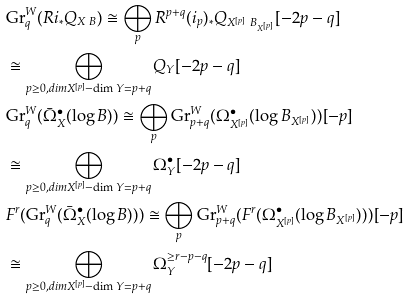Convert formula to latex. <formula><loc_0><loc_0><loc_500><loc_500>& \text {Gr} _ { q } ^ { W } ( R i _ { * } Q _ { X \ B } ) \cong \bigoplus _ { p } R ^ { p + q } ( i _ { p } ) _ { * } Q _ { X ^ { [ p ] } \ B _ { X ^ { [ p ] } } } [ - 2 p - q ] \\ & \cong \bigoplus _ { p \geq 0 , d i m X ^ { [ p ] } - \dim Y = p + q } Q _ { Y } [ - 2 p - q ] \\ & \text {Gr} _ { q } ^ { W } ( \bar { \Omega } ^ { \bullet } _ { X } ( \log B ) ) \cong \bigoplus _ { p } \text {Gr} _ { p + q } ^ { W } ( \Omega ^ { \bullet } _ { X ^ { [ p ] } } ( \log B _ { X ^ { [ p ] } } ) ) [ - p ] \\ & \cong \bigoplus _ { p \geq 0 , d i m X ^ { [ p ] } - \dim Y = p + q } \Omega _ { Y } ^ { \bullet } [ - 2 p - q ] \\ & F ^ { r } ( \text {Gr} _ { q } ^ { W } ( \bar { \Omega } ^ { \bullet } _ { X } ( \log B ) ) ) \cong \bigoplus _ { p } \text {Gr} _ { p + q } ^ { W } ( F ^ { r } ( \Omega ^ { \bullet } _ { X ^ { [ p ] } } ( \log B _ { X ^ { [ p ] } } ) ) ) [ - p ] \\ & \cong \bigoplus _ { p \geq 0 , d i m X ^ { [ p ] } - \dim Y = p + q } \Omega _ { Y } ^ { \geq r - p - q } [ - 2 p - q ]</formula> 